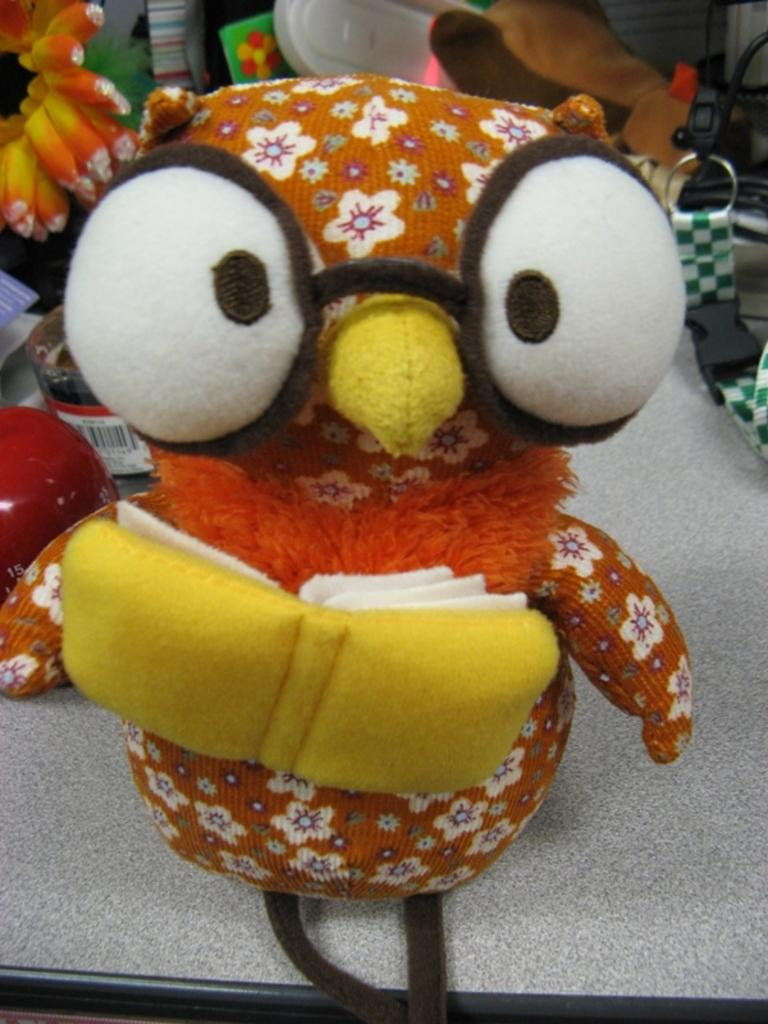What type of objects can be seen in the image? There are toys in the image. Can you identify any other objects besides the toys? Yes, there is a bottle in the image. Are there any other items or "things" visible in the image? Yes, there are unspecified "things" in the image. What channel is the seed being broadcasted on in the image? There is no seed or channel present in the image. What type of show is being aired on the seed in the image? There is no seed or show present in the image. 